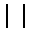Convert formula to latex. <formula><loc_0><loc_0><loc_500><loc_500>| \ |</formula> 